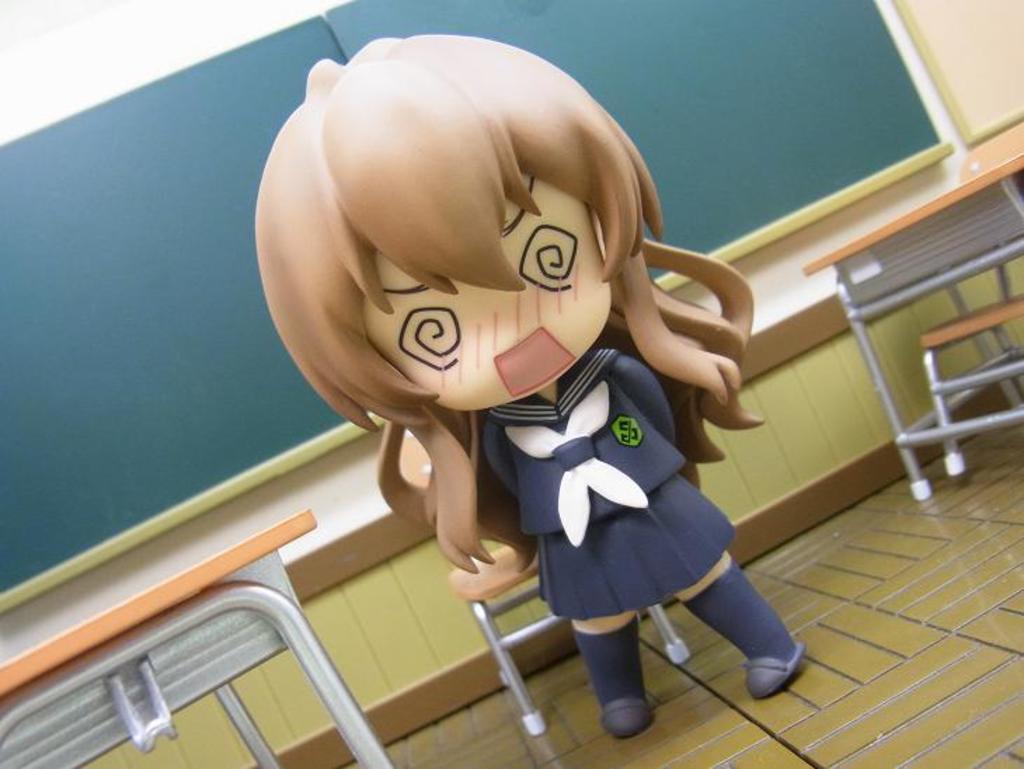Can you describe this image briefly? There is a doll. There are tables and chairs. In the background there are boards on the wall. 